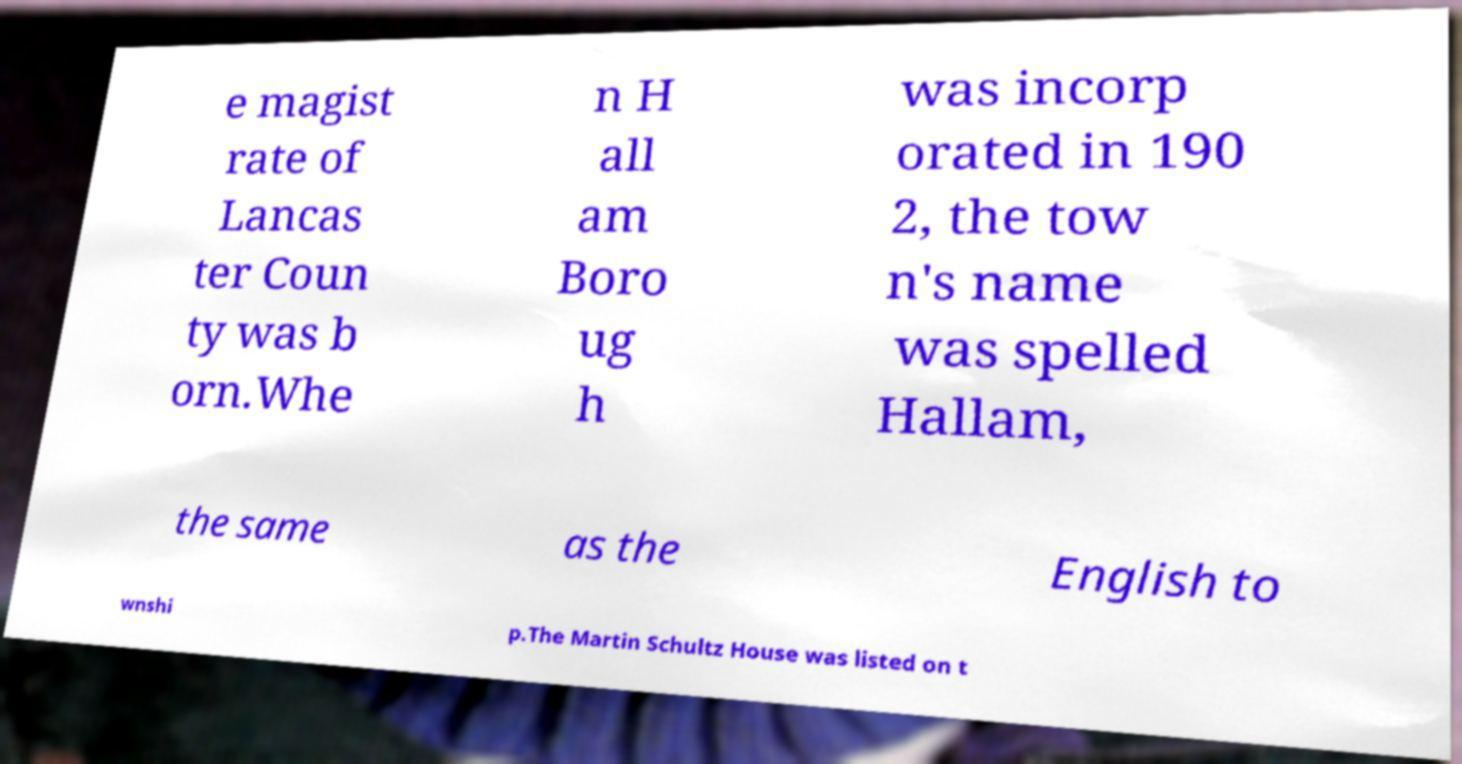There's text embedded in this image that I need extracted. Can you transcribe it verbatim? e magist rate of Lancas ter Coun ty was b orn.Whe n H all am Boro ug h was incorp orated in 190 2, the tow n's name was spelled Hallam, the same as the English to wnshi p.The Martin Schultz House was listed on t 